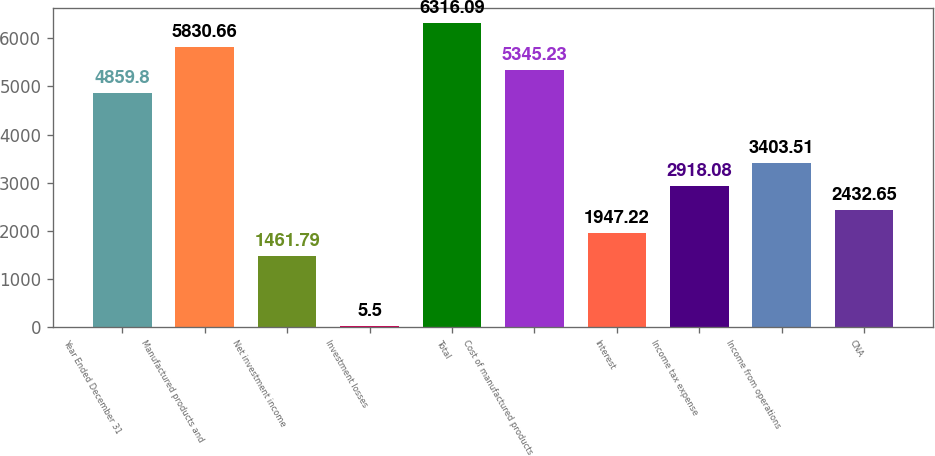Convert chart. <chart><loc_0><loc_0><loc_500><loc_500><bar_chart><fcel>Year Ended December 31<fcel>Manufactured products and<fcel>Net investment income<fcel>Investment losses<fcel>Total<fcel>Cost of manufactured products<fcel>Interest<fcel>Income tax expense<fcel>Income from operations<fcel>CNA<nl><fcel>4859.8<fcel>5830.66<fcel>1461.79<fcel>5.5<fcel>6316.09<fcel>5345.23<fcel>1947.22<fcel>2918.08<fcel>3403.51<fcel>2432.65<nl></chart> 